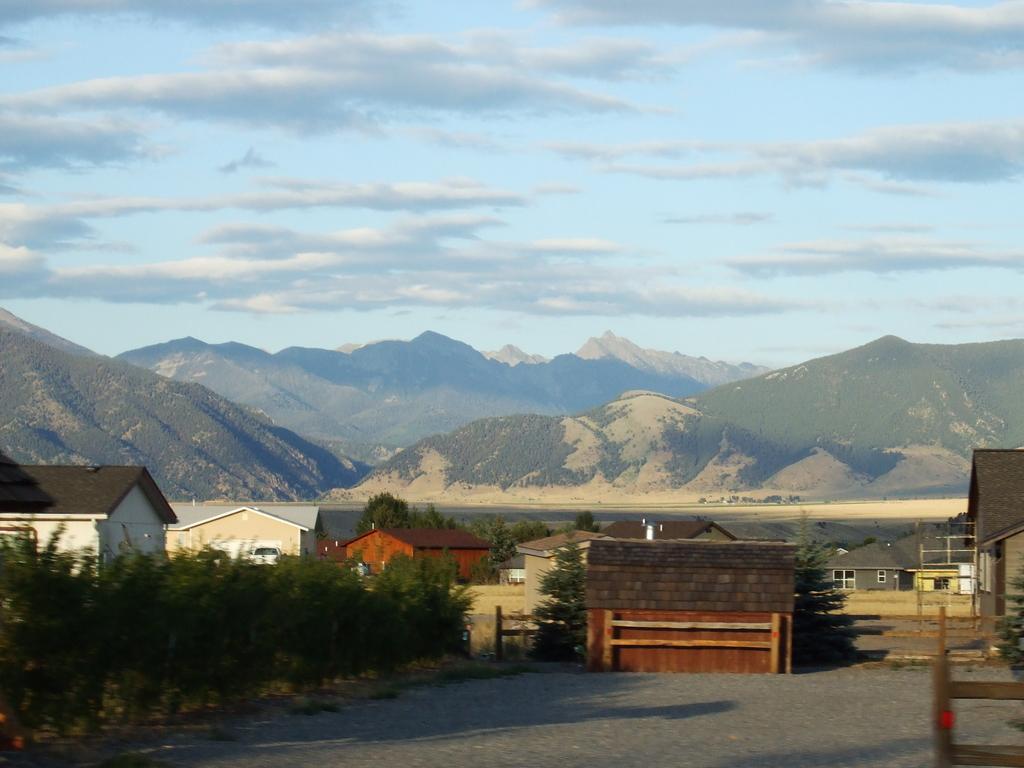Please provide a concise description of this image. There are houses and trees in the foreground area of the image, there are mountains and the sky in the background. 